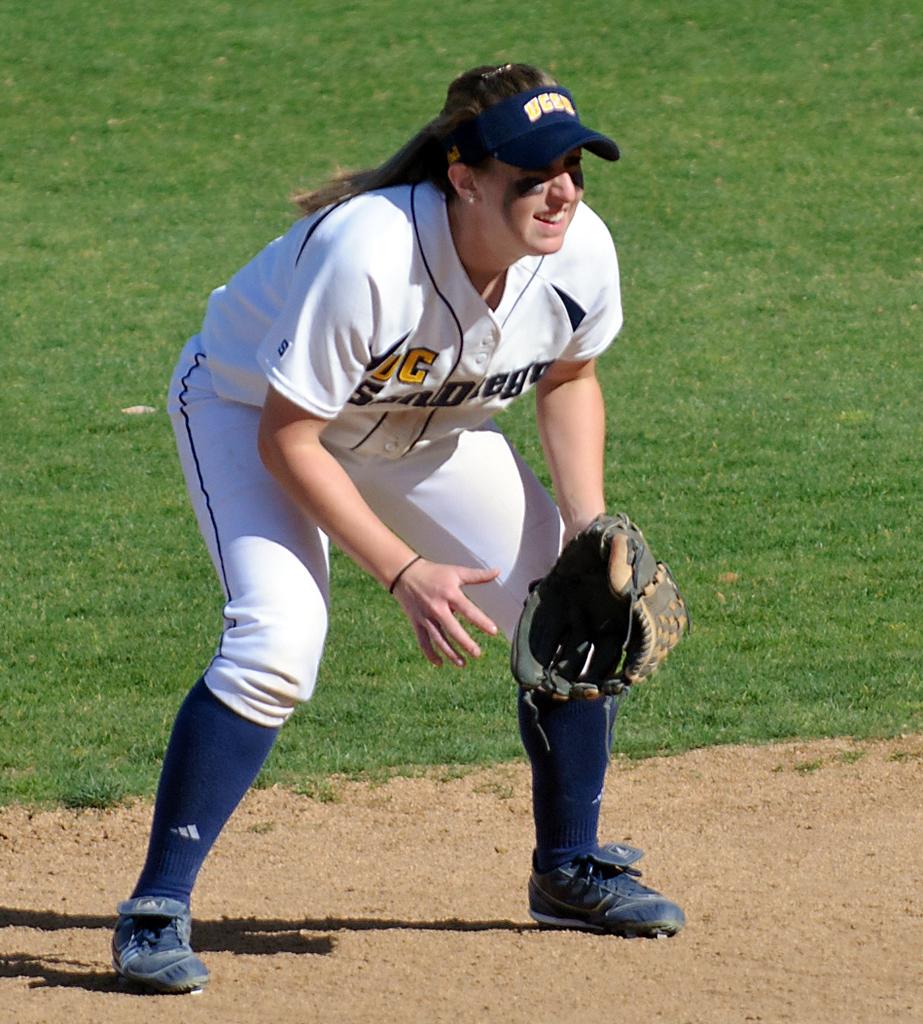Are her socks adidas?
Provide a short and direct response. Yes. 